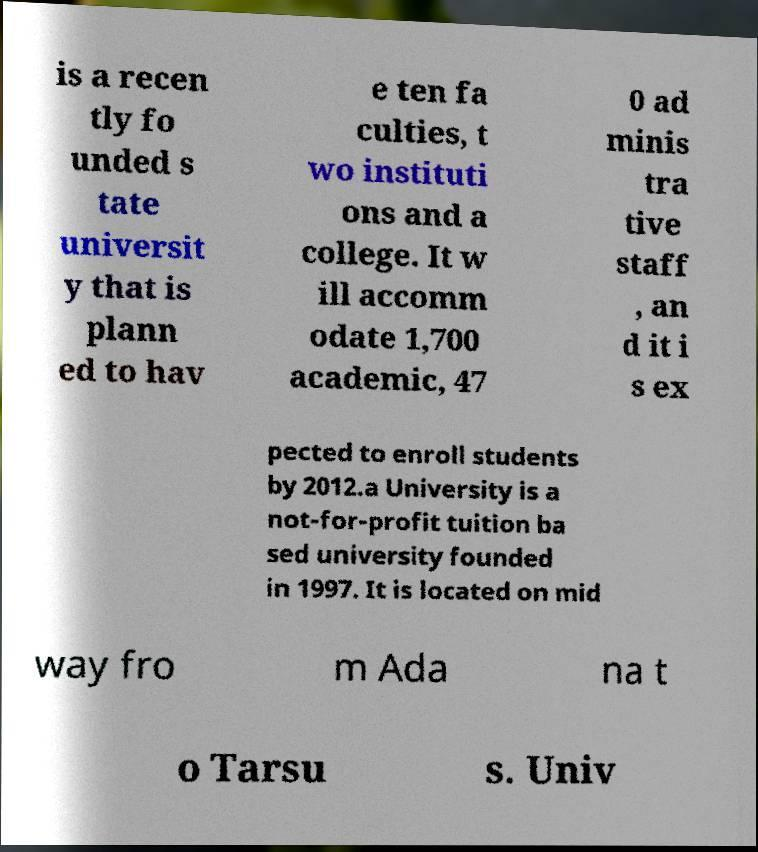Can you accurately transcribe the text from the provided image for me? is a recen tly fo unded s tate universit y that is plann ed to hav e ten fa culties, t wo instituti ons and a college. It w ill accomm odate 1,700 academic, 47 0 ad minis tra tive staff , an d it i s ex pected to enroll students by 2012.a University is a not-for-profit tuition ba sed university founded in 1997. It is located on mid way fro m Ada na t o Tarsu s. Univ 